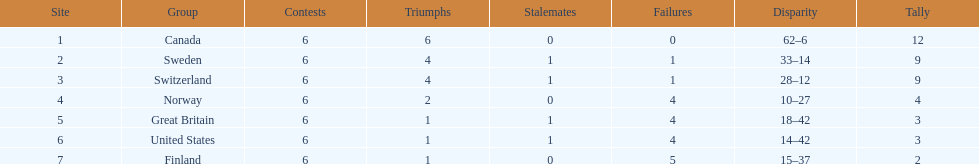What team placed next after sweden? Switzerland. 